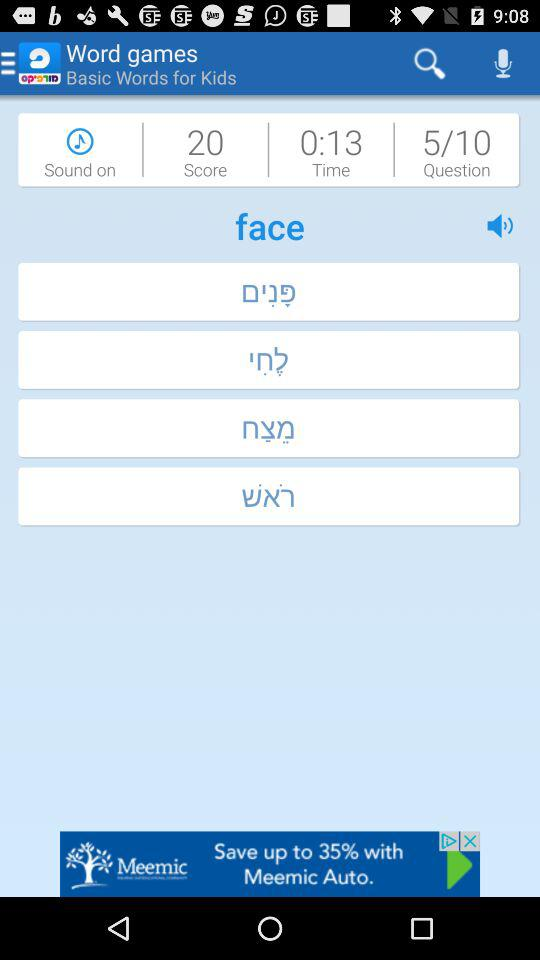How many questions in total are there? There are 10 questions in total. 